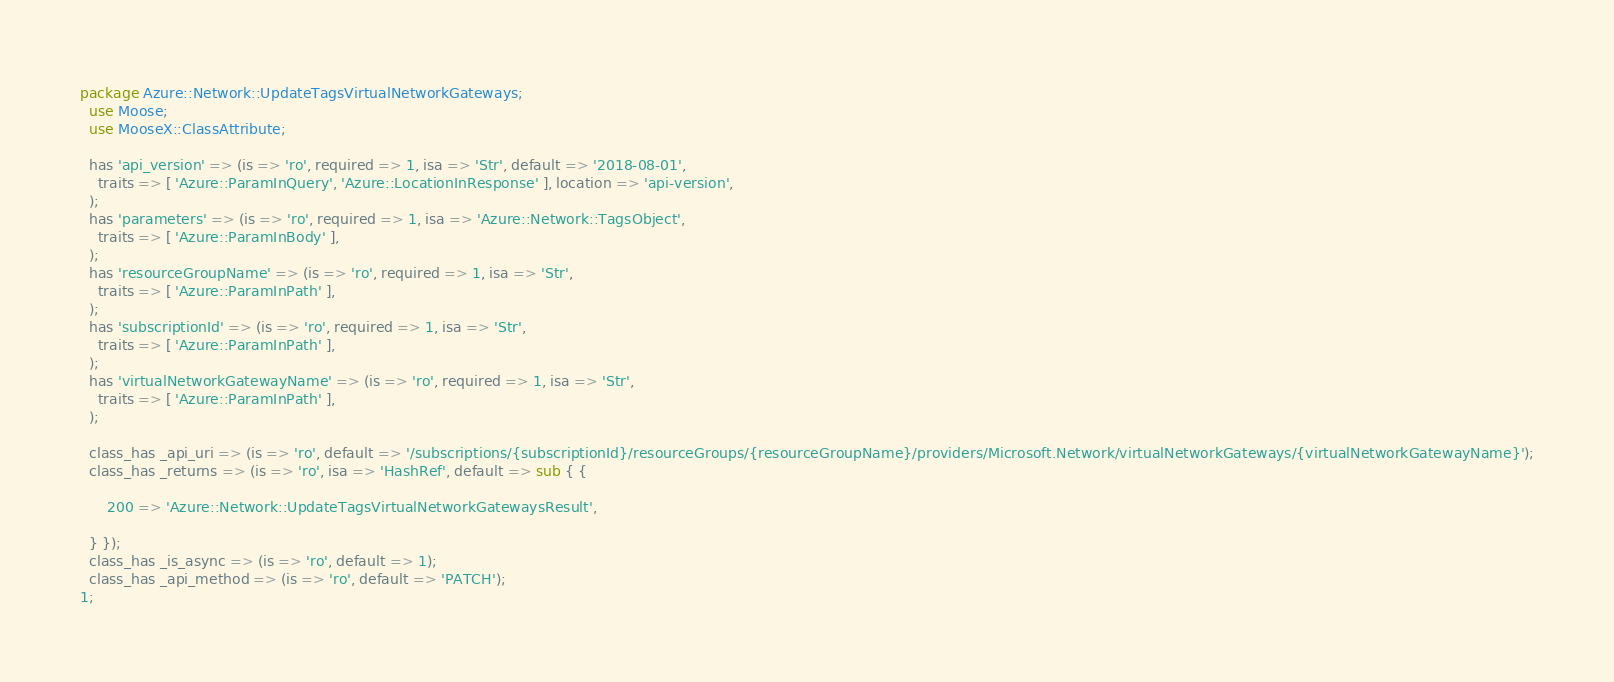<code> <loc_0><loc_0><loc_500><loc_500><_Perl_>package Azure::Network::UpdateTagsVirtualNetworkGateways;
  use Moose;
  use MooseX::ClassAttribute;

  has 'api_version' => (is => 'ro', required => 1, isa => 'Str', default => '2018-08-01',
    traits => [ 'Azure::ParamInQuery', 'Azure::LocationInResponse' ], location => 'api-version',
  );
  has 'parameters' => (is => 'ro', required => 1, isa => 'Azure::Network::TagsObject',
    traits => [ 'Azure::ParamInBody' ],
  );
  has 'resourceGroupName' => (is => 'ro', required => 1, isa => 'Str',
    traits => [ 'Azure::ParamInPath' ],
  );
  has 'subscriptionId' => (is => 'ro', required => 1, isa => 'Str',
    traits => [ 'Azure::ParamInPath' ],
  );
  has 'virtualNetworkGatewayName' => (is => 'ro', required => 1, isa => 'Str',
    traits => [ 'Azure::ParamInPath' ],
  );

  class_has _api_uri => (is => 'ro', default => '/subscriptions/{subscriptionId}/resourceGroups/{resourceGroupName}/providers/Microsoft.Network/virtualNetworkGateways/{virtualNetworkGatewayName}');
  class_has _returns => (is => 'ro', isa => 'HashRef', default => sub { {
    
      200 => 'Azure::Network::UpdateTagsVirtualNetworkGatewaysResult',
    
  } });
  class_has _is_async => (is => 'ro', default => 1);
  class_has _api_method => (is => 'ro', default => 'PATCH');
1;
</code> 